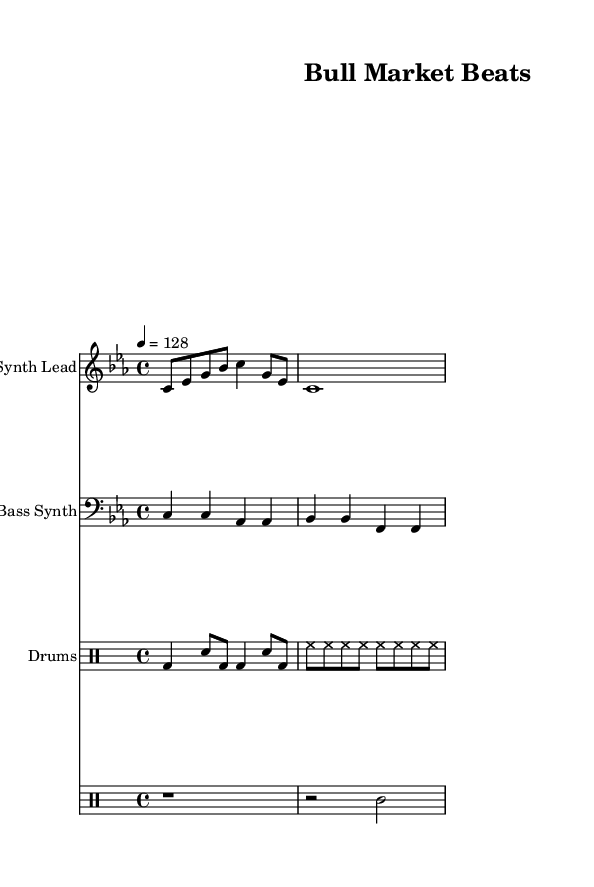What is the key signature of this music? The key signature is indicated in the opening of the score, showing C minor, which includes three flats (B♭, E♭, A♭).
Answer: C minor What is the time signature of this music? The time signature is displayed next to the key signature; it is 4/4, meaning there are four beats in a measure, with a quarter note receiving one beat.
Answer: 4/4 What is the tempo of the piece? The tempo indication states "4 = 128", meaning the quarter note is played at a speed of 128 beats per minute, which is moderately fast for dance music.
Answer: 128 How many bars are in the synth lead? By counting the measures in the synth lead staff, there are a total of 2 bars present in this section of the score.
Answer: 2 Which instruments are present in the score? The score includes three parts: a Synth Lead, a Bass Synth, and Drums, as indicated by the labeled staves.
Answer: Synth Lead, Bass Synth, Drums Describe the nature of the drum pattern used. The drum pattern consists of a bass drum (bd) and snare (sn) combination, along with a high hat (hh), indicative of traditional dance music rhythms meant for energetic movements.
Answer: Energetic rhythm 